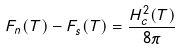Convert formula to latex. <formula><loc_0><loc_0><loc_500><loc_500>F _ { n } ( T ) - F _ { s } ( T ) = \frac { H _ { c } ^ { 2 } ( T ) } { 8 \pi }</formula> 